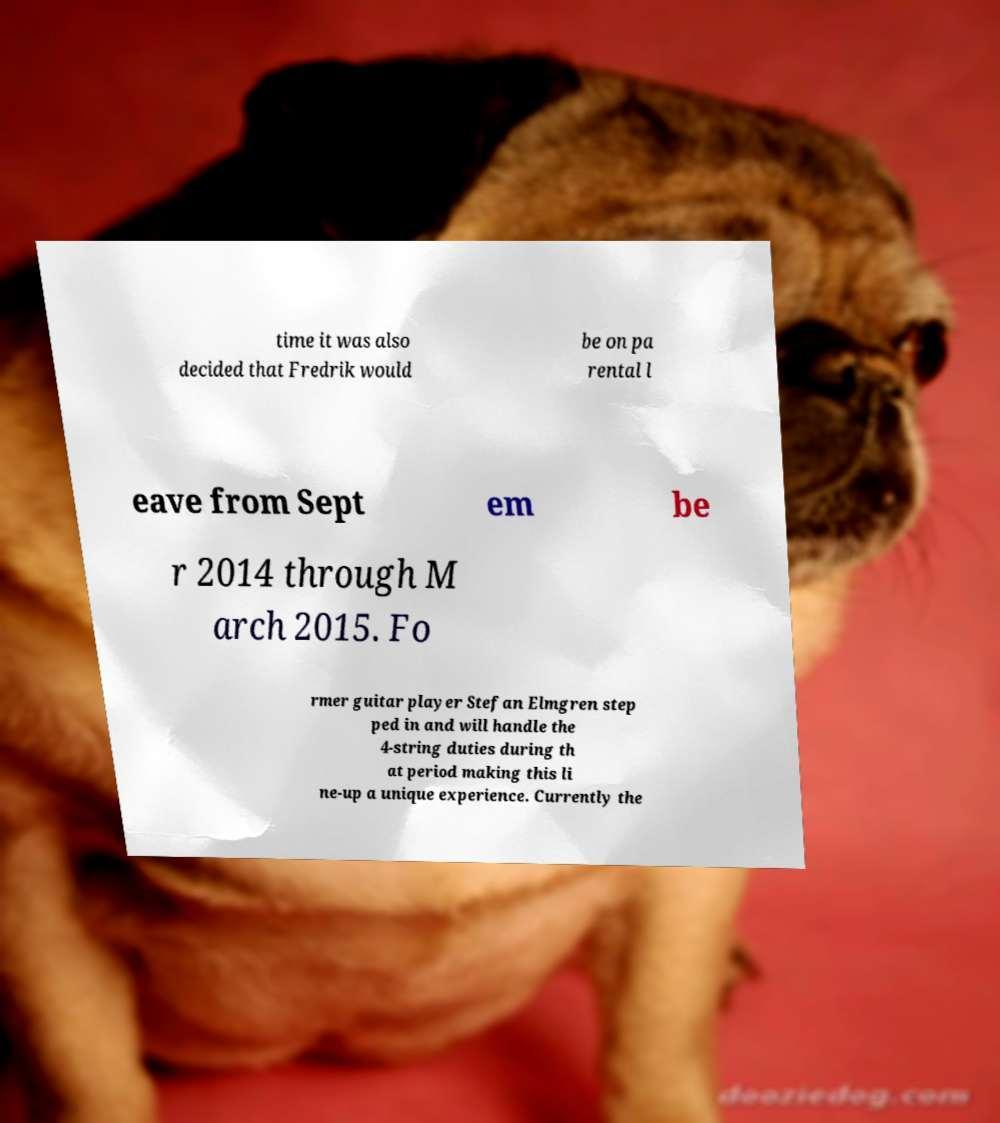There's text embedded in this image that I need extracted. Can you transcribe it verbatim? time it was also decided that Fredrik would be on pa rental l eave from Sept em be r 2014 through M arch 2015. Fo rmer guitar player Stefan Elmgren step ped in and will handle the 4-string duties during th at period making this li ne-up a unique experience. Currently the 